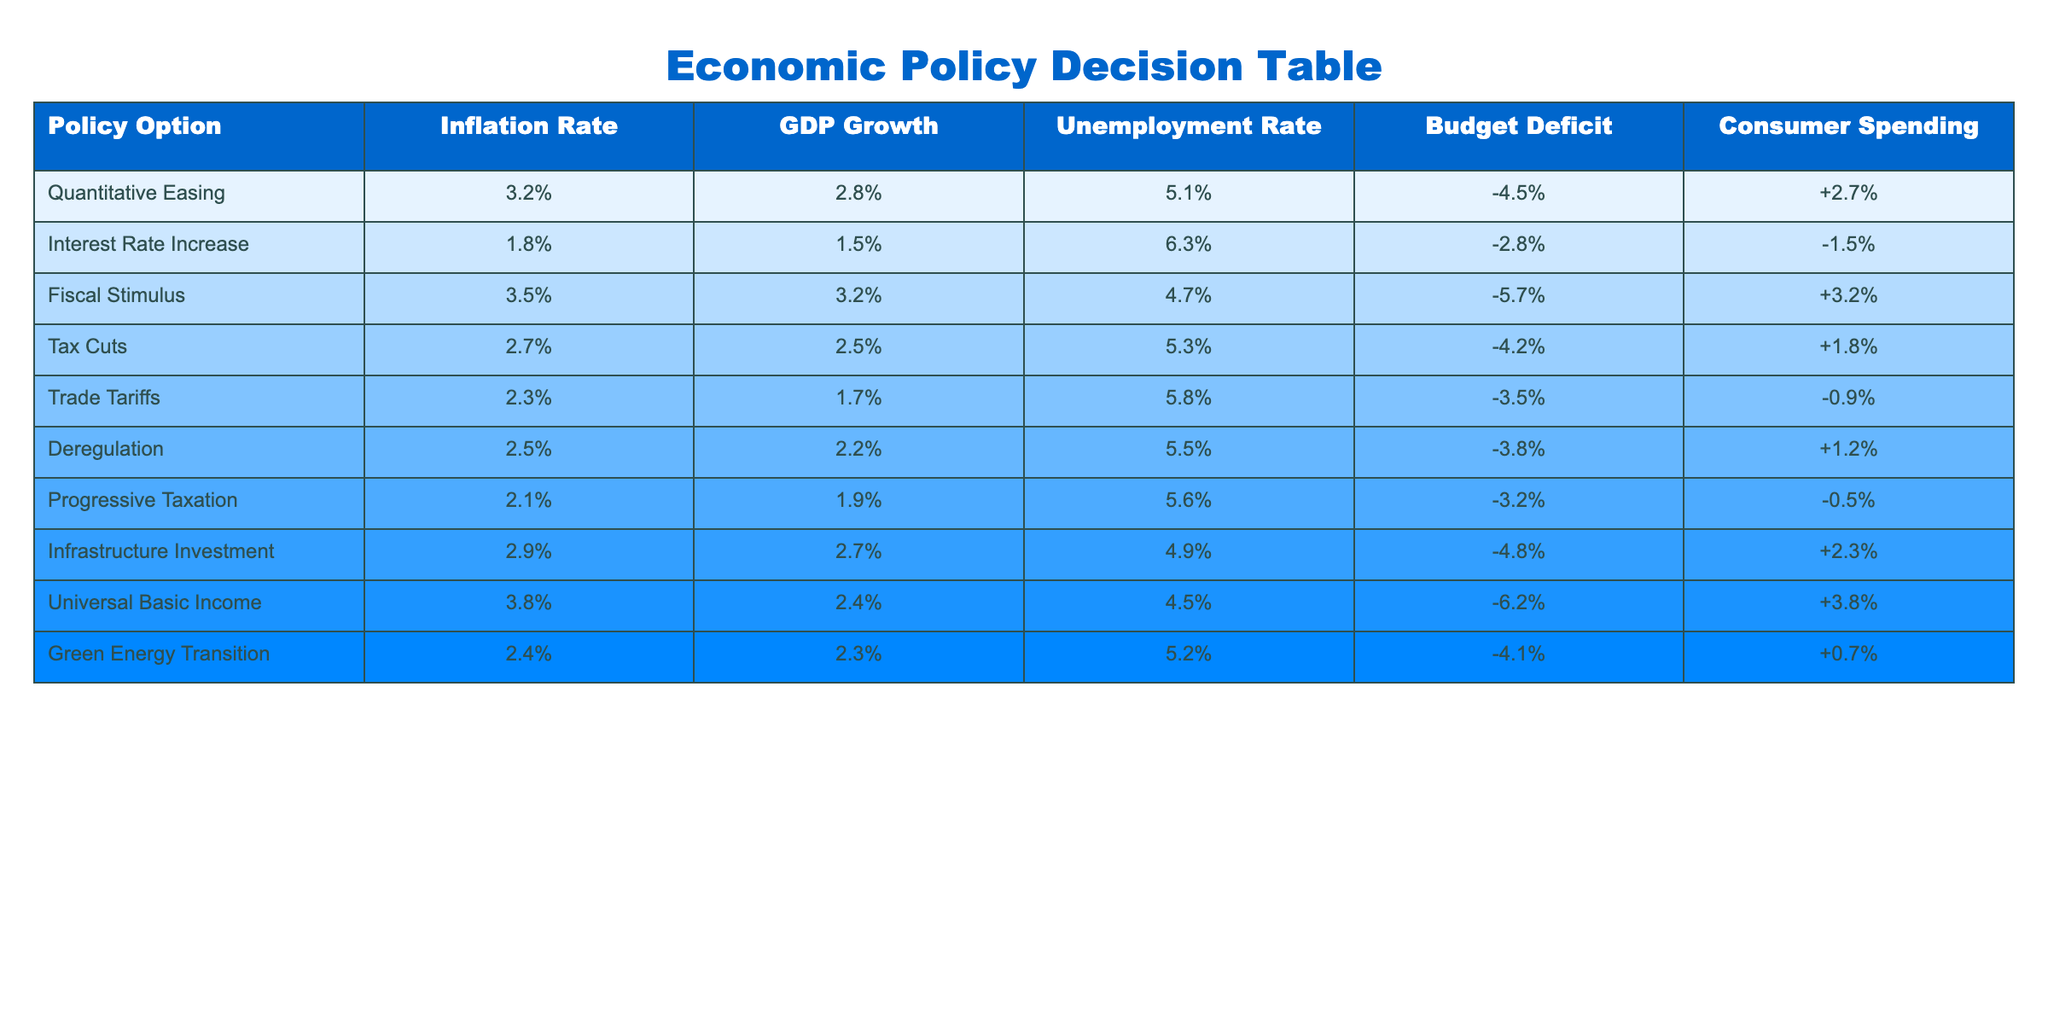What is the inflation rate associated with Fiscal Stimulus? Looking at the table, under the Fiscal Stimulus policy option, the inflation rate is listed as 3.5%.
Answer: 3.5% Which policy option results in the highest GDP growth? To find the highest GDP growth, we check the GDP Growth column and identify that Fiscal Stimulus has the highest value at 3.2%.
Answer: Fiscal Stimulus Is the unemployment rate higher for the Interest Rate Increase option than for the Tax Cuts option? The unemployment rate for Interest Rate Increase is 6.3%, while for Tax Cuts, it is 5.3%. Since 6.3% is greater than 5.3%, the answer is yes.
Answer: Yes What is the difference in budget deficit between Universal Basic Income and Deregulation? The budget deficit for Universal Basic Income is -6.2%, and for Deregulation, it is -3.8%. To find the difference, we calculate -6.2 - (-3.8) = -2.4.
Answer: -2.4% What is the average consumer spending rate for the two policy options with the lowest inflation rates? The two lowest inflation rates are for Trade Tariffs (2.3%) and Progressive Taxation (2.1%). Their consumer spending rates are -0.9% and -0.5%, respectively. The average is calculated as (-0.9 + (-0.5)) / 2 = -0.7.
Answer: -0.7 Does Quantitative Easing result in a higher consumer spending rate than Trade Tariffs? The consumer spending rate for Quantitative Easing is +2.7%, while for Trade Tariffs, it is -0.9%. Since +2.7% is greater than -0.9%, the answer is yes.
Answer: Yes What is the policy option with the lowest unemployment rate, and what is its value? Reviewing the unemployment rates in the table, the lowest rate is for Fiscal Stimulus, which has a 4.7% unemployment rate.
Answer: Fiscal Stimulus, 4.7% If we calculate the total budget deficit for all policy options, what will it represent? To find the total budget deficit, we sum all the budget deficits: -4.5 + (-2.8) + (-5.7) + (-4.2) + (-3.5) + (-3.8) + (-3.2) + (-4.8) + (-6.2) = -38.7.
Answer: -38.7 What is the predicted GDP growth rate for Green Energy Transition? In the GDP Growth column, Green Energy Transition shows a growth rate of 2.3%.
Answer: 2.3% 